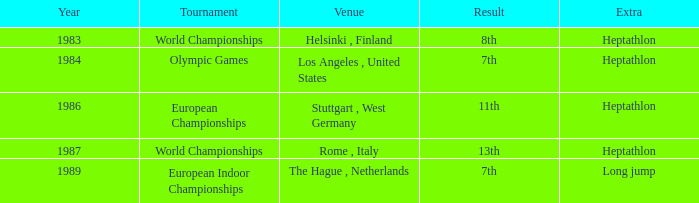Where was the 1984 Olympics hosted? Olympic Games. 